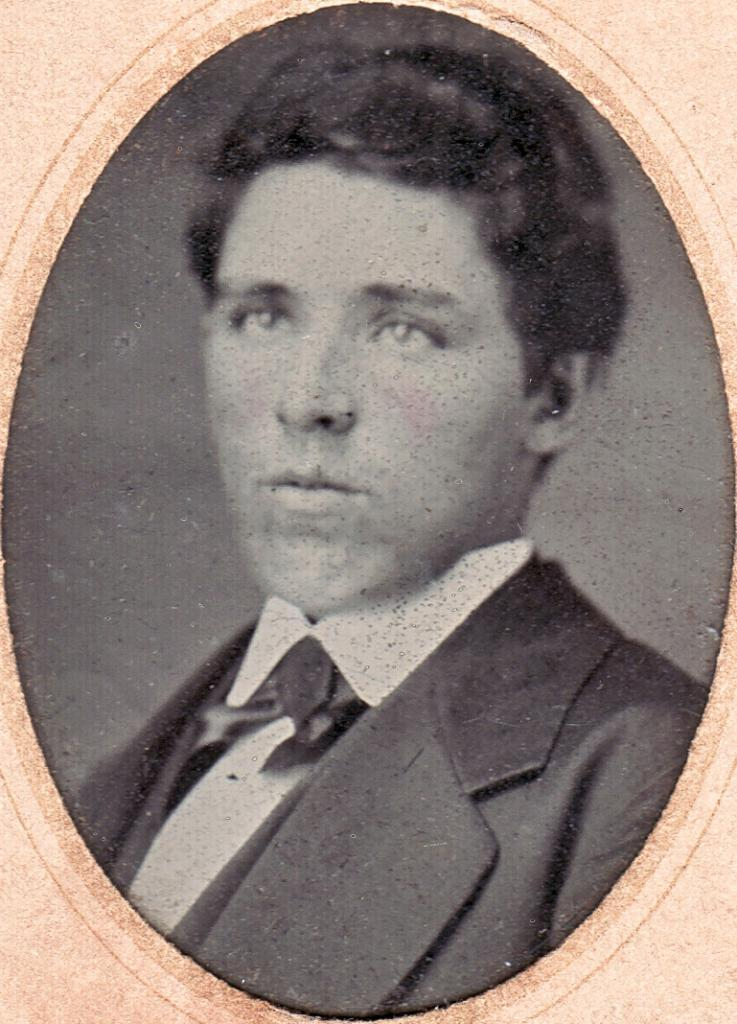What is the main subject of the image? There is a depiction of a person in the center of the image. How many quince are present in the image? There is no mention of quince in the image, so it cannot be determined if any are present. 